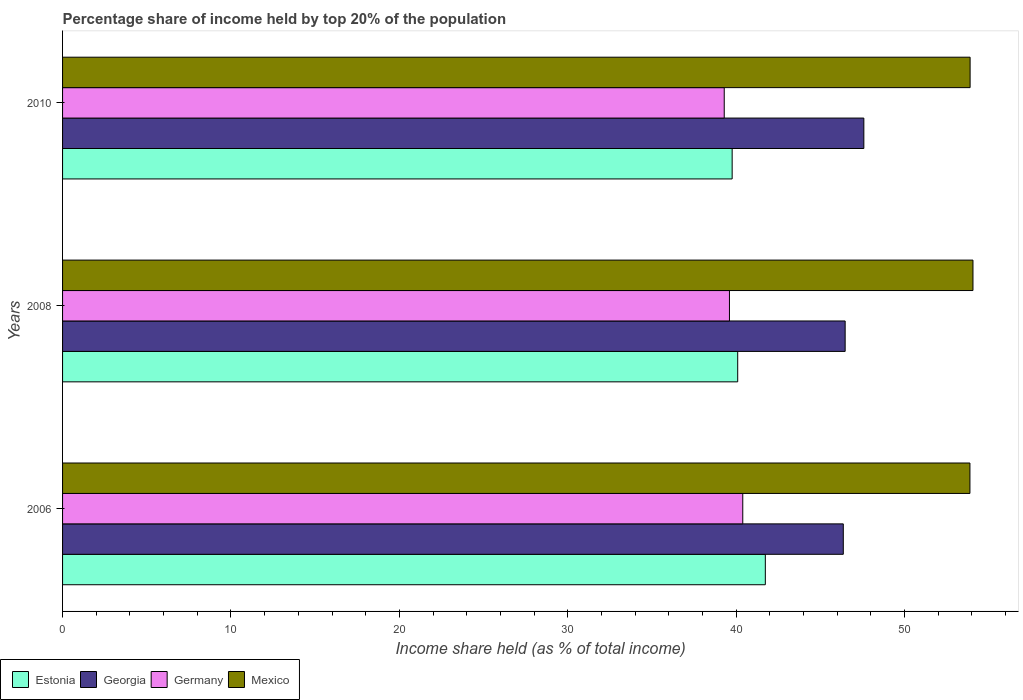How many different coloured bars are there?
Offer a terse response. 4. Are the number of bars on each tick of the Y-axis equal?
Provide a short and direct response. Yes. What is the percentage share of income held by top 20% of the population in Germany in 2008?
Provide a succinct answer. 39.6. Across all years, what is the maximum percentage share of income held by top 20% of the population in Germany?
Your answer should be very brief. 40.39. Across all years, what is the minimum percentage share of income held by top 20% of the population in Estonia?
Make the answer very short. 39.76. In which year was the percentage share of income held by top 20% of the population in Estonia maximum?
Your answer should be very brief. 2006. In which year was the percentage share of income held by top 20% of the population in Estonia minimum?
Provide a short and direct response. 2010. What is the total percentage share of income held by top 20% of the population in Estonia in the graph?
Provide a short and direct response. 121.58. What is the difference between the percentage share of income held by top 20% of the population in Germany in 2006 and that in 2008?
Offer a very short reply. 0.79. What is the difference between the percentage share of income held by top 20% of the population in Estonia in 2010 and the percentage share of income held by top 20% of the population in Mexico in 2008?
Provide a short and direct response. -14.3. What is the average percentage share of income held by top 20% of the population in Georgia per year?
Your answer should be compact. 46.8. In the year 2008, what is the difference between the percentage share of income held by top 20% of the population in Estonia and percentage share of income held by top 20% of the population in Germany?
Your answer should be very brief. 0.49. In how many years, is the percentage share of income held by top 20% of the population in Mexico greater than 36 %?
Give a very brief answer. 3. What is the ratio of the percentage share of income held by top 20% of the population in Germany in 2006 to that in 2010?
Your answer should be very brief. 1.03. Is the difference between the percentage share of income held by top 20% of the population in Estonia in 2008 and 2010 greater than the difference between the percentage share of income held by top 20% of the population in Germany in 2008 and 2010?
Your response must be concise. Yes. What is the difference between the highest and the second highest percentage share of income held by top 20% of the population in Estonia?
Offer a very short reply. 1.64. What is the difference between the highest and the lowest percentage share of income held by top 20% of the population in Georgia?
Offer a terse response. 1.22. Is the sum of the percentage share of income held by top 20% of the population in Georgia in 2008 and 2010 greater than the maximum percentage share of income held by top 20% of the population in Mexico across all years?
Offer a very short reply. Yes. Is it the case that in every year, the sum of the percentage share of income held by top 20% of the population in Germany and percentage share of income held by top 20% of the population in Mexico is greater than the sum of percentage share of income held by top 20% of the population in Georgia and percentage share of income held by top 20% of the population in Estonia?
Ensure brevity in your answer.  Yes. What does the 4th bar from the top in 2010 represents?
Provide a short and direct response. Estonia. What does the 2nd bar from the bottom in 2010 represents?
Offer a terse response. Georgia. Are all the bars in the graph horizontal?
Your answer should be very brief. Yes. Are the values on the major ticks of X-axis written in scientific E-notation?
Make the answer very short. No. What is the title of the graph?
Provide a short and direct response. Percentage share of income held by top 20% of the population. What is the label or title of the X-axis?
Give a very brief answer. Income share held (as % of total income). What is the Income share held (as % of total income) of Estonia in 2006?
Give a very brief answer. 41.73. What is the Income share held (as % of total income) of Georgia in 2006?
Give a very brief answer. 46.36. What is the Income share held (as % of total income) in Germany in 2006?
Provide a short and direct response. 40.39. What is the Income share held (as % of total income) of Mexico in 2006?
Make the answer very short. 53.88. What is the Income share held (as % of total income) of Estonia in 2008?
Give a very brief answer. 40.09. What is the Income share held (as % of total income) in Georgia in 2008?
Give a very brief answer. 46.47. What is the Income share held (as % of total income) in Germany in 2008?
Provide a succinct answer. 39.6. What is the Income share held (as % of total income) of Mexico in 2008?
Offer a very short reply. 54.06. What is the Income share held (as % of total income) in Estonia in 2010?
Give a very brief answer. 39.76. What is the Income share held (as % of total income) of Georgia in 2010?
Provide a short and direct response. 47.58. What is the Income share held (as % of total income) in Germany in 2010?
Your answer should be very brief. 39.29. What is the Income share held (as % of total income) in Mexico in 2010?
Ensure brevity in your answer.  53.89. Across all years, what is the maximum Income share held (as % of total income) in Estonia?
Offer a very short reply. 41.73. Across all years, what is the maximum Income share held (as % of total income) of Georgia?
Provide a short and direct response. 47.58. Across all years, what is the maximum Income share held (as % of total income) in Germany?
Your answer should be compact. 40.39. Across all years, what is the maximum Income share held (as % of total income) of Mexico?
Your answer should be very brief. 54.06. Across all years, what is the minimum Income share held (as % of total income) of Estonia?
Your answer should be very brief. 39.76. Across all years, what is the minimum Income share held (as % of total income) in Georgia?
Provide a short and direct response. 46.36. Across all years, what is the minimum Income share held (as % of total income) of Germany?
Ensure brevity in your answer.  39.29. Across all years, what is the minimum Income share held (as % of total income) of Mexico?
Offer a very short reply. 53.88. What is the total Income share held (as % of total income) in Estonia in the graph?
Your response must be concise. 121.58. What is the total Income share held (as % of total income) in Georgia in the graph?
Give a very brief answer. 140.41. What is the total Income share held (as % of total income) of Germany in the graph?
Provide a short and direct response. 119.28. What is the total Income share held (as % of total income) of Mexico in the graph?
Offer a very short reply. 161.83. What is the difference between the Income share held (as % of total income) in Estonia in 2006 and that in 2008?
Your response must be concise. 1.64. What is the difference between the Income share held (as % of total income) in Georgia in 2006 and that in 2008?
Provide a short and direct response. -0.11. What is the difference between the Income share held (as % of total income) in Germany in 2006 and that in 2008?
Your answer should be compact. 0.79. What is the difference between the Income share held (as % of total income) of Mexico in 2006 and that in 2008?
Offer a terse response. -0.18. What is the difference between the Income share held (as % of total income) in Estonia in 2006 and that in 2010?
Ensure brevity in your answer.  1.97. What is the difference between the Income share held (as % of total income) in Georgia in 2006 and that in 2010?
Make the answer very short. -1.22. What is the difference between the Income share held (as % of total income) of Mexico in 2006 and that in 2010?
Make the answer very short. -0.01. What is the difference between the Income share held (as % of total income) of Estonia in 2008 and that in 2010?
Your response must be concise. 0.33. What is the difference between the Income share held (as % of total income) in Georgia in 2008 and that in 2010?
Offer a very short reply. -1.11. What is the difference between the Income share held (as % of total income) of Germany in 2008 and that in 2010?
Your answer should be compact. 0.31. What is the difference between the Income share held (as % of total income) in Mexico in 2008 and that in 2010?
Keep it short and to the point. 0.17. What is the difference between the Income share held (as % of total income) in Estonia in 2006 and the Income share held (as % of total income) in Georgia in 2008?
Offer a terse response. -4.74. What is the difference between the Income share held (as % of total income) of Estonia in 2006 and the Income share held (as % of total income) of Germany in 2008?
Keep it short and to the point. 2.13. What is the difference between the Income share held (as % of total income) in Estonia in 2006 and the Income share held (as % of total income) in Mexico in 2008?
Your answer should be compact. -12.33. What is the difference between the Income share held (as % of total income) in Georgia in 2006 and the Income share held (as % of total income) in Germany in 2008?
Keep it short and to the point. 6.76. What is the difference between the Income share held (as % of total income) of Georgia in 2006 and the Income share held (as % of total income) of Mexico in 2008?
Offer a very short reply. -7.7. What is the difference between the Income share held (as % of total income) in Germany in 2006 and the Income share held (as % of total income) in Mexico in 2008?
Keep it short and to the point. -13.67. What is the difference between the Income share held (as % of total income) in Estonia in 2006 and the Income share held (as % of total income) in Georgia in 2010?
Provide a short and direct response. -5.85. What is the difference between the Income share held (as % of total income) in Estonia in 2006 and the Income share held (as % of total income) in Germany in 2010?
Your answer should be compact. 2.44. What is the difference between the Income share held (as % of total income) of Estonia in 2006 and the Income share held (as % of total income) of Mexico in 2010?
Make the answer very short. -12.16. What is the difference between the Income share held (as % of total income) of Georgia in 2006 and the Income share held (as % of total income) of Germany in 2010?
Provide a succinct answer. 7.07. What is the difference between the Income share held (as % of total income) of Georgia in 2006 and the Income share held (as % of total income) of Mexico in 2010?
Provide a short and direct response. -7.53. What is the difference between the Income share held (as % of total income) in Estonia in 2008 and the Income share held (as % of total income) in Georgia in 2010?
Your response must be concise. -7.49. What is the difference between the Income share held (as % of total income) in Estonia in 2008 and the Income share held (as % of total income) in Germany in 2010?
Provide a short and direct response. 0.8. What is the difference between the Income share held (as % of total income) in Georgia in 2008 and the Income share held (as % of total income) in Germany in 2010?
Provide a succinct answer. 7.18. What is the difference between the Income share held (as % of total income) of Georgia in 2008 and the Income share held (as % of total income) of Mexico in 2010?
Offer a terse response. -7.42. What is the difference between the Income share held (as % of total income) of Germany in 2008 and the Income share held (as % of total income) of Mexico in 2010?
Provide a short and direct response. -14.29. What is the average Income share held (as % of total income) of Estonia per year?
Provide a short and direct response. 40.53. What is the average Income share held (as % of total income) in Georgia per year?
Offer a terse response. 46.8. What is the average Income share held (as % of total income) of Germany per year?
Your answer should be very brief. 39.76. What is the average Income share held (as % of total income) of Mexico per year?
Your response must be concise. 53.94. In the year 2006, what is the difference between the Income share held (as % of total income) in Estonia and Income share held (as % of total income) in Georgia?
Provide a short and direct response. -4.63. In the year 2006, what is the difference between the Income share held (as % of total income) in Estonia and Income share held (as % of total income) in Germany?
Offer a very short reply. 1.34. In the year 2006, what is the difference between the Income share held (as % of total income) of Estonia and Income share held (as % of total income) of Mexico?
Provide a short and direct response. -12.15. In the year 2006, what is the difference between the Income share held (as % of total income) in Georgia and Income share held (as % of total income) in Germany?
Your response must be concise. 5.97. In the year 2006, what is the difference between the Income share held (as % of total income) in Georgia and Income share held (as % of total income) in Mexico?
Provide a succinct answer. -7.52. In the year 2006, what is the difference between the Income share held (as % of total income) of Germany and Income share held (as % of total income) of Mexico?
Make the answer very short. -13.49. In the year 2008, what is the difference between the Income share held (as % of total income) in Estonia and Income share held (as % of total income) in Georgia?
Make the answer very short. -6.38. In the year 2008, what is the difference between the Income share held (as % of total income) in Estonia and Income share held (as % of total income) in Germany?
Keep it short and to the point. 0.49. In the year 2008, what is the difference between the Income share held (as % of total income) in Estonia and Income share held (as % of total income) in Mexico?
Offer a very short reply. -13.97. In the year 2008, what is the difference between the Income share held (as % of total income) in Georgia and Income share held (as % of total income) in Germany?
Keep it short and to the point. 6.87. In the year 2008, what is the difference between the Income share held (as % of total income) of Georgia and Income share held (as % of total income) of Mexico?
Make the answer very short. -7.59. In the year 2008, what is the difference between the Income share held (as % of total income) of Germany and Income share held (as % of total income) of Mexico?
Your response must be concise. -14.46. In the year 2010, what is the difference between the Income share held (as % of total income) in Estonia and Income share held (as % of total income) in Georgia?
Give a very brief answer. -7.82. In the year 2010, what is the difference between the Income share held (as % of total income) in Estonia and Income share held (as % of total income) in Germany?
Give a very brief answer. 0.47. In the year 2010, what is the difference between the Income share held (as % of total income) of Estonia and Income share held (as % of total income) of Mexico?
Offer a very short reply. -14.13. In the year 2010, what is the difference between the Income share held (as % of total income) in Georgia and Income share held (as % of total income) in Germany?
Your answer should be very brief. 8.29. In the year 2010, what is the difference between the Income share held (as % of total income) in Georgia and Income share held (as % of total income) in Mexico?
Ensure brevity in your answer.  -6.31. In the year 2010, what is the difference between the Income share held (as % of total income) of Germany and Income share held (as % of total income) of Mexico?
Your answer should be compact. -14.6. What is the ratio of the Income share held (as % of total income) of Estonia in 2006 to that in 2008?
Your answer should be very brief. 1.04. What is the ratio of the Income share held (as % of total income) of Georgia in 2006 to that in 2008?
Your answer should be compact. 1. What is the ratio of the Income share held (as % of total income) in Germany in 2006 to that in 2008?
Provide a succinct answer. 1.02. What is the ratio of the Income share held (as % of total income) in Mexico in 2006 to that in 2008?
Your answer should be compact. 1. What is the ratio of the Income share held (as % of total income) in Estonia in 2006 to that in 2010?
Your answer should be compact. 1.05. What is the ratio of the Income share held (as % of total income) in Georgia in 2006 to that in 2010?
Offer a very short reply. 0.97. What is the ratio of the Income share held (as % of total income) in Germany in 2006 to that in 2010?
Give a very brief answer. 1.03. What is the ratio of the Income share held (as % of total income) of Mexico in 2006 to that in 2010?
Offer a terse response. 1. What is the ratio of the Income share held (as % of total income) of Estonia in 2008 to that in 2010?
Your response must be concise. 1.01. What is the ratio of the Income share held (as % of total income) of Georgia in 2008 to that in 2010?
Your response must be concise. 0.98. What is the ratio of the Income share held (as % of total income) in Germany in 2008 to that in 2010?
Keep it short and to the point. 1.01. What is the ratio of the Income share held (as % of total income) of Mexico in 2008 to that in 2010?
Give a very brief answer. 1. What is the difference between the highest and the second highest Income share held (as % of total income) in Estonia?
Offer a very short reply. 1.64. What is the difference between the highest and the second highest Income share held (as % of total income) of Georgia?
Give a very brief answer. 1.11. What is the difference between the highest and the second highest Income share held (as % of total income) of Germany?
Your answer should be very brief. 0.79. What is the difference between the highest and the second highest Income share held (as % of total income) of Mexico?
Your answer should be compact. 0.17. What is the difference between the highest and the lowest Income share held (as % of total income) of Estonia?
Your response must be concise. 1.97. What is the difference between the highest and the lowest Income share held (as % of total income) of Georgia?
Give a very brief answer. 1.22. What is the difference between the highest and the lowest Income share held (as % of total income) of Germany?
Your answer should be very brief. 1.1. What is the difference between the highest and the lowest Income share held (as % of total income) in Mexico?
Offer a very short reply. 0.18. 